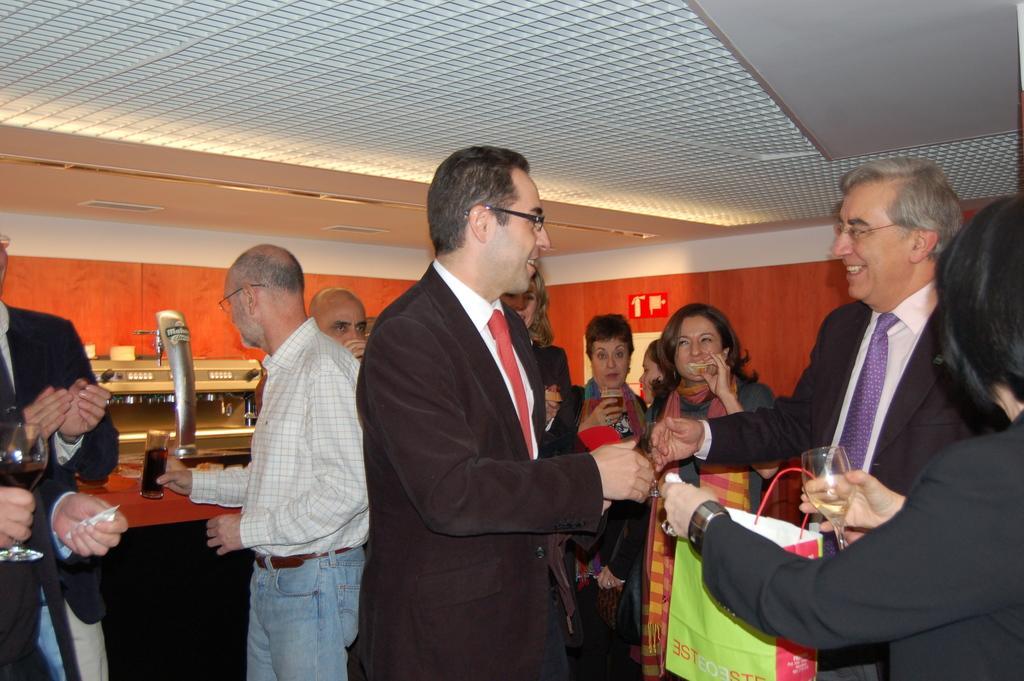Could you give a brief overview of what you see in this image? Here we can see group of people and they are holding glasses with their hands. In the background we can see a board, wall, and lights. This is ceiling. 